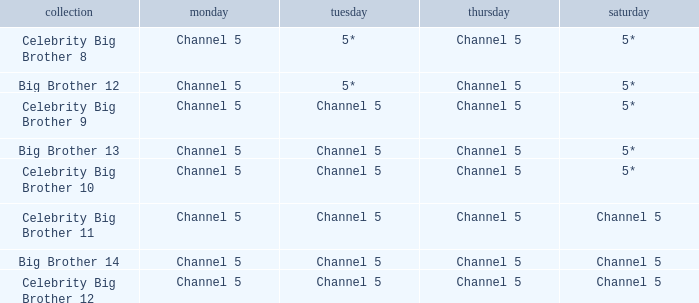Which Tuesday does big brother 12 air? 5*. 